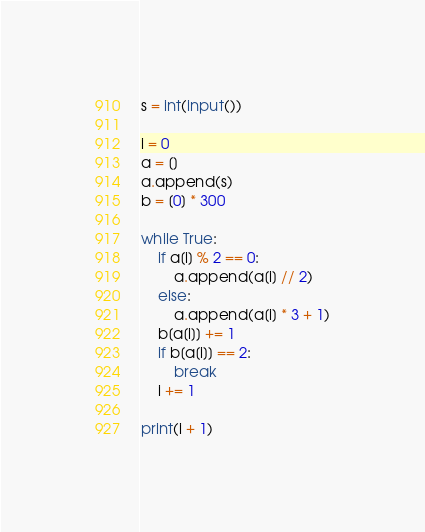Convert code to text. <code><loc_0><loc_0><loc_500><loc_500><_Python_>s = int(input())

i = 0
a = []
a.append(s)
b = [0] * 300

while True:
    if a[i] % 2 == 0:
        a.append(a[i] // 2)
    else:
        a.append(a[i] * 3 + 1)
    b[a[i]] += 1
    if b[a[i]] == 2:
        break
    i += 1

print(i + 1)</code> 